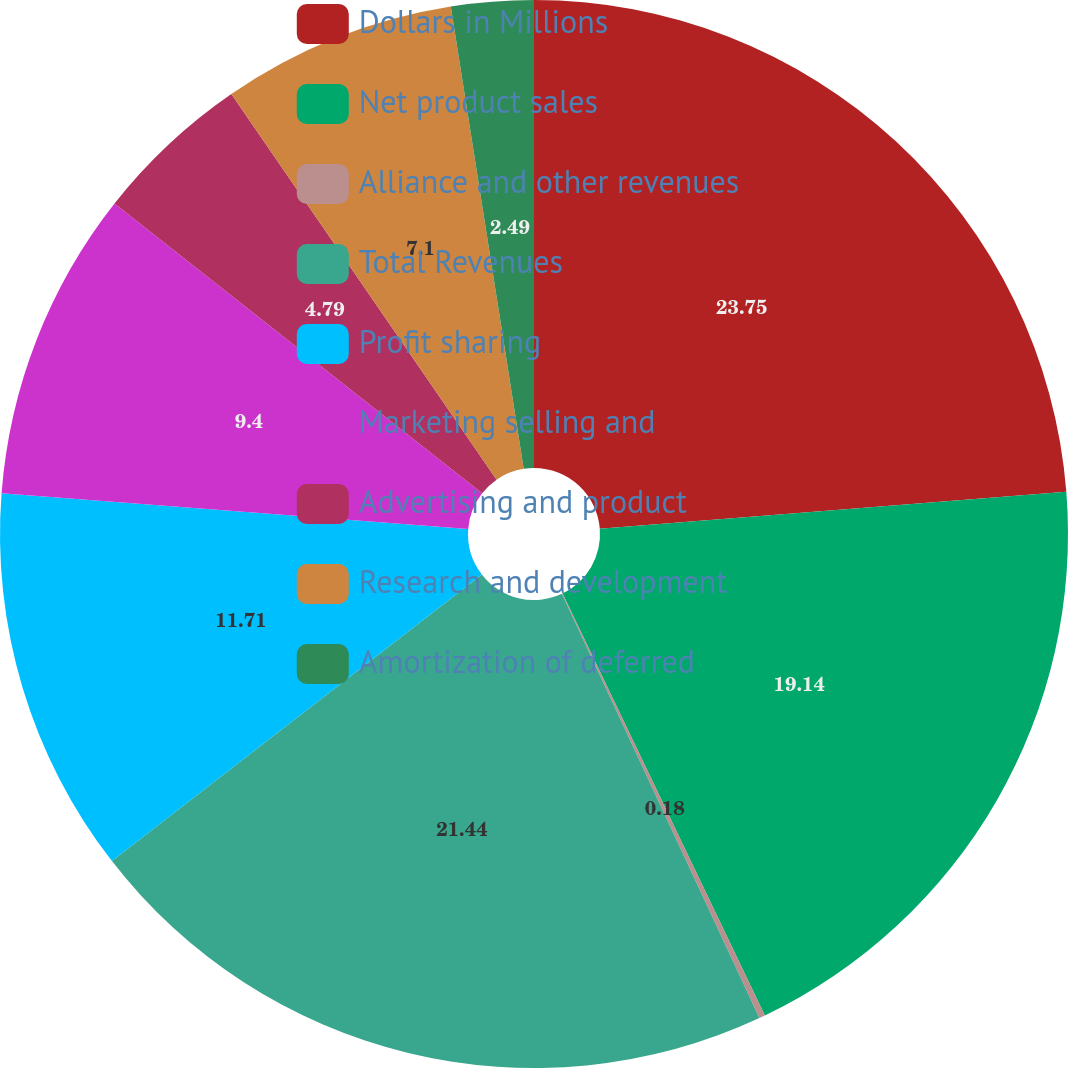Convert chart to OTSL. <chart><loc_0><loc_0><loc_500><loc_500><pie_chart><fcel>Dollars in Millions<fcel>Net product sales<fcel>Alliance and other revenues<fcel>Total Revenues<fcel>Profit sharing<fcel>Marketing selling and<fcel>Advertising and product<fcel>Research and development<fcel>Amortization of deferred<nl><fcel>23.74%<fcel>19.14%<fcel>0.18%<fcel>21.44%<fcel>11.71%<fcel>9.4%<fcel>4.79%<fcel>7.1%<fcel>2.49%<nl></chart> 